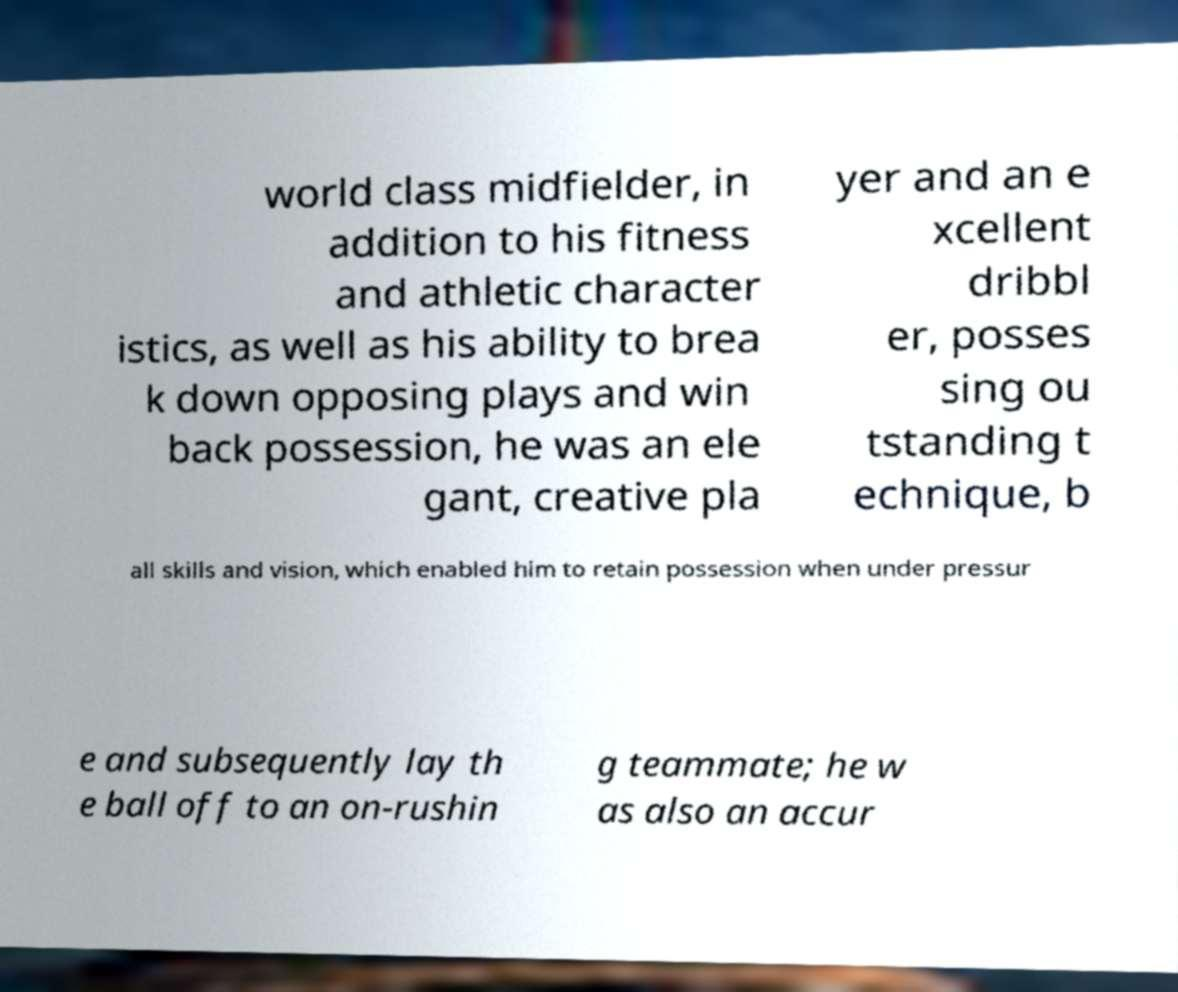I need the written content from this picture converted into text. Can you do that? world class midfielder, in addition to his fitness and athletic character istics, as well as his ability to brea k down opposing plays and win back possession, he was an ele gant, creative pla yer and an e xcellent dribbl er, posses sing ou tstanding t echnique, b all skills and vision, which enabled him to retain possession when under pressur e and subsequently lay th e ball off to an on-rushin g teammate; he w as also an accur 